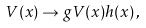<formula> <loc_0><loc_0><loc_500><loc_500>V ( x ) \rightarrow g V ( x ) h ( x ) \, ,</formula> 